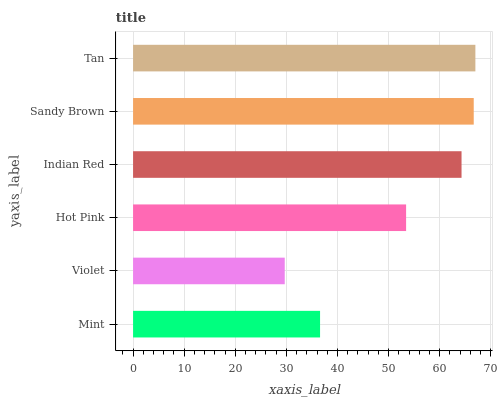Is Violet the minimum?
Answer yes or no. Yes. Is Tan the maximum?
Answer yes or no. Yes. Is Hot Pink the minimum?
Answer yes or no. No. Is Hot Pink the maximum?
Answer yes or no. No. Is Hot Pink greater than Violet?
Answer yes or no. Yes. Is Violet less than Hot Pink?
Answer yes or no. Yes. Is Violet greater than Hot Pink?
Answer yes or no. No. Is Hot Pink less than Violet?
Answer yes or no. No. Is Indian Red the high median?
Answer yes or no. Yes. Is Hot Pink the low median?
Answer yes or no. Yes. Is Mint the high median?
Answer yes or no. No. Is Indian Red the low median?
Answer yes or no. No. 